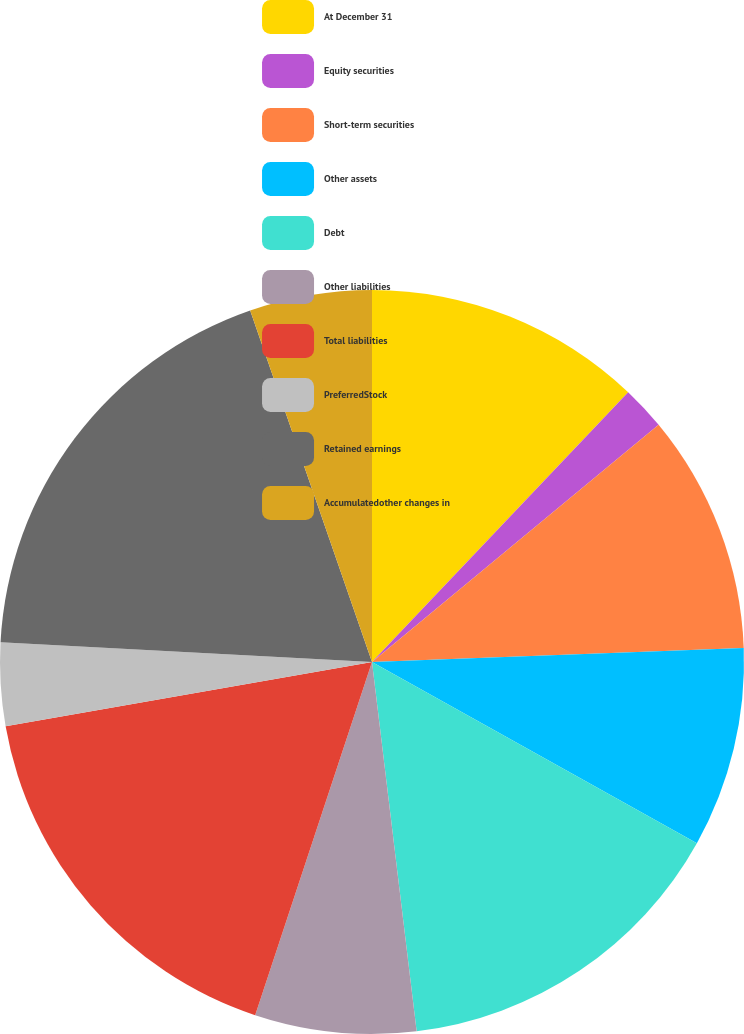Convert chart. <chart><loc_0><loc_0><loc_500><loc_500><pie_chart><fcel>At December 31<fcel>Equity securities<fcel>Short-term securities<fcel>Other assets<fcel>Debt<fcel>Other liabilities<fcel>Total liabilities<fcel>PreferredStock<fcel>Retained earnings<fcel>Accumulatedother changes in<nl><fcel>12.09%<fcel>1.91%<fcel>10.4%<fcel>8.7%<fcel>14.99%<fcel>7.0%<fcel>17.15%<fcel>3.61%<fcel>18.85%<fcel>5.31%<nl></chart> 